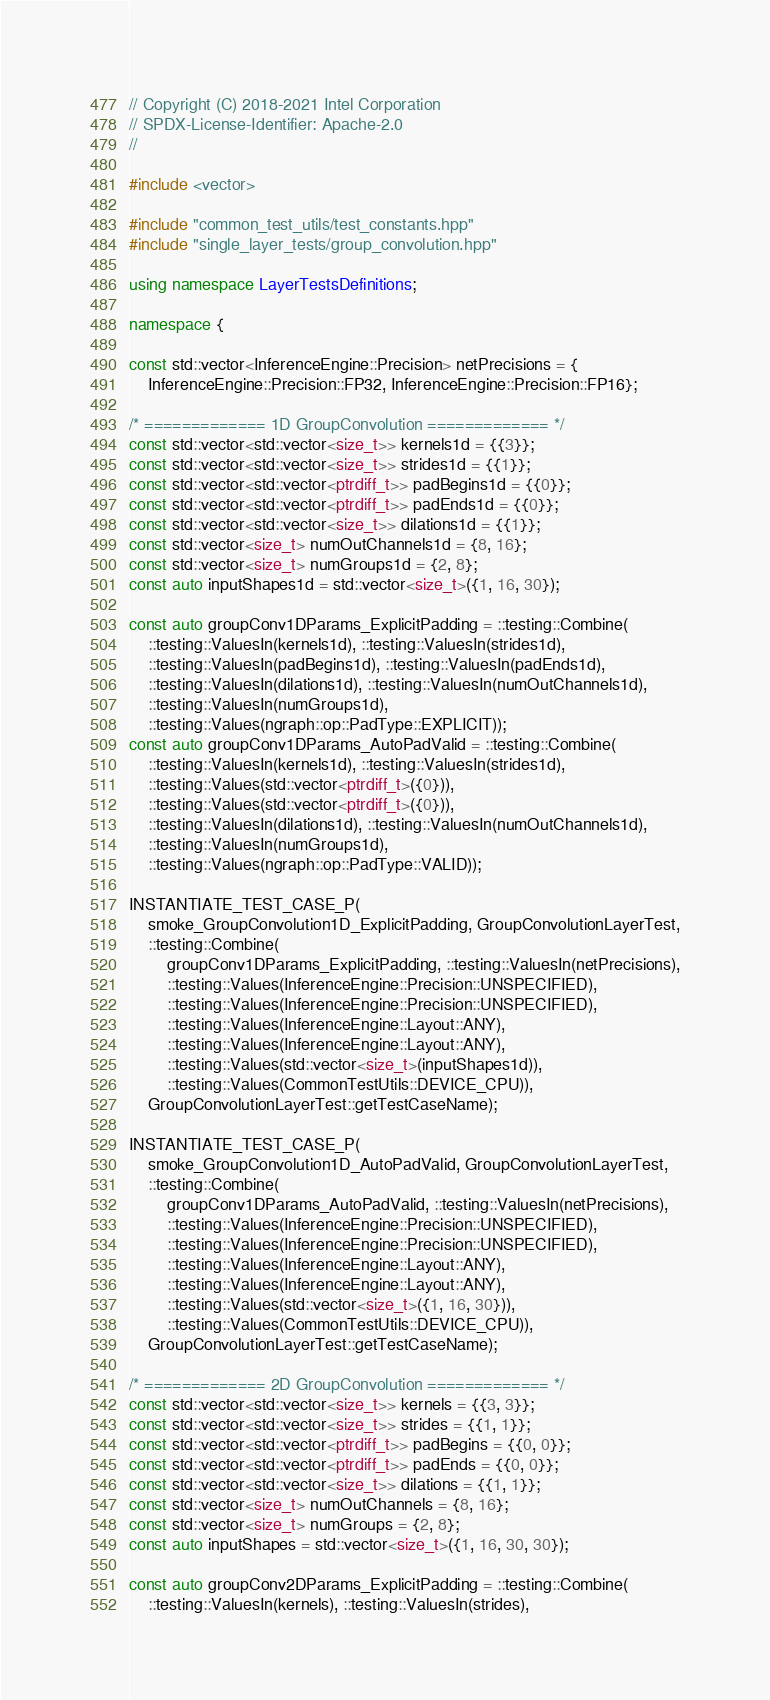Convert code to text. <code><loc_0><loc_0><loc_500><loc_500><_C++_>// Copyright (C) 2018-2021 Intel Corporation
// SPDX-License-Identifier: Apache-2.0
//

#include <vector>

#include "common_test_utils/test_constants.hpp"
#include "single_layer_tests/group_convolution.hpp"

using namespace LayerTestsDefinitions;

namespace {

const std::vector<InferenceEngine::Precision> netPrecisions = {
    InferenceEngine::Precision::FP32, InferenceEngine::Precision::FP16};

/* ============= 1D GroupConvolution ============= */
const std::vector<std::vector<size_t>> kernels1d = {{3}};
const std::vector<std::vector<size_t>> strides1d = {{1}};
const std::vector<std::vector<ptrdiff_t>> padBegins1d = {{0}};
const std::vector<std::vector<ptrdiff_t>> padEnds1d = {{0}};
const std::vector<std::vector<size_t>> dilations1d = {{1}};
const std::vector<size_t> numOutChannels1d = {8, 16};
const std::vector<size_t> numGroups1d = {2, 8};
const auto inputShapes1d = std::vector<size_t>({1, 16, 30});

const auto groupConv1DParams_ExplicitPadding = ::testing::Combine(
    ::testing::ValuesIn(kernels1d), ::testing::ValuesIn(strides1d),
    ::testing::ValuesIn(padBegins1d), ::testing::ValuesIn(padEnds1d),
    ::testing::ValuesIn(dilations1d), ::testing::ValuesIn(numOutChannels1d),
    ::testing::ValuesIn(numGroups1d),
    ::testing::Values(ngraph::op::PadType::EXPLICIT));
const auto groupConv1DParams_AutoPadValid = ::testing::Combine(
    ::testing::ValuesIn(kernels1d), ::testing::ValuesIn(strides1d),
    ::testing::Values(std::vector<ptrdiff_t>({0})),
    ::testing::Values(std::vector<ptrdiff_t>({0})),
    ::testing::ValuesIn(dilations1d), ::testing::ValuesIn(numOutChannels1d),
    ::testing::ValuesIn(numGroups1d),
    ::testing::Values(ngraph::op::PadType::VALID));

INSTANTIATE_TEST_CASE_P(
    smoke_GroupConvolution1D_ExplicitPadding, GroupConvolutionLayerTest,
    ::testing::Combine(
        groupConv1DParams_ExplicitPadding, ::testing::ValuesIn(netPrecisions),
        ::testing::Values(InferenceEngine::Precision::UNSPECIFIED),
        ::testing::Values(InferenceEngine::Precision::UNSPECIFIED),
        ::testing::Values(InferenceEngine::Layout::ANY),
        ::testing::Values(InferenceEngine::Layout::ANY),
        ::testing::Values(std::vector<size_t>(inputShapes1d)),
        ::testing::Values(CommonTestUtils::DEVICE_CPU)),
    GroupConvolutionLayerTest::getTestCaseName);

INSTANTIATE_TEST_CASE_P(
    smoke_GroupConvolution1D_AutoPadValid, GroupConvolutionLayerTest,
    ::testing::Combine(
        groupConv1DParams_AutoPadValid, ::testing::ValuesIn(netPrecisions),
        ::testing::Values(InferenceEngine::Precision::UNSPECIFIED),
        ::testing::Values(InferenceEngine::Precision::UNSPECIFIED),
        ::testing::Values(InferenceEngine::Layout::ANY),
        ::testing::Values(InferenceEngine::Layout::ANY),
        ::testing::Values(std::vector<size_t>({1, 16, 30})),
        ::testing::Values(CommonTestUtils::DEVICE_CPU)),
    GroupConvolutionLayerTest::getTestCaseName);

/* ============= 2D GroupConvolution ============= */
const std::vector<std::vector<size_t>> kernels = {{3, 3}};
const std::vector<std::vector<size_t>> strides = {{1, 1}};
const std::vector<std::vector<ptrdiff_t>> padBegins = {{0, 0}};
const std::vector<std::vector<ptrdiff_t>> padEnds = {{0, 0}};
const std::vector<std::vector<size_t>> dilations = {{1, 1}};
const std::vector<size_t> numOutChannels = {8, 16};
const std::vector<size_t> numGroups = {2, 8};
const auto inputShapes = std::vector<size_t>({1, 16, 30, 30});

const auto groupConv2DParams_ExplicitPadding = ::testing::Combine(
    ::testing::ValuesIn(kernels), ::testing::ValuesIn(strides),</code> 